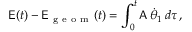Convert formula to latex. <formula><loc_0><loc_0><loc_500><loc_500>E ( t ) - E _ { g e o m } ( t ) = \int _ { 0 } ^ { t } A \, \dot { \theta } _ { 1 } \, d \tau \, ,</formula> 